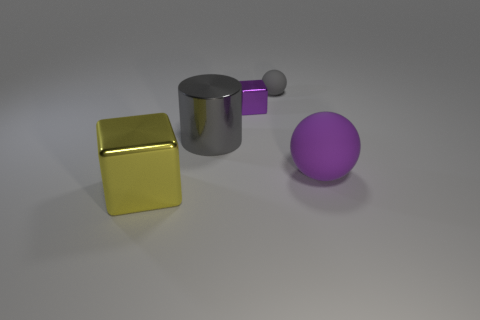What shape is the tiny purple thing that is the same material as the large yellow cube?
Keep it short and to the point. Cube. Is the material of the tiny block the same as the big sphere?
Your answer should be compact. No. Are there fewer big metal things that are on the right side of the purple matte thing than small purple shiny cubes that are behind the large yellow metallic thing?
Your answer should be very brief. Yes. What is the size of the matte sphere that is the same color as the small cube?
Make the answer very short. Large. What number of big gray cylinders are to the right of the big metallic thing in front of the large object to the right of the tiny gray matte ball?
Ensure brevity in your answer.  1. Do the large cylinder and the big ball have the same color?
Offer a very short reply. No. Are there any tiny objects of the same color as the tiny cube?
Make the answer very short. No. There is a metallic cube that is the same size as the purple matte ball; what color is it?
Ensure brevity in your answer.  Yellow. Is there a large yellow object that has the same shape as the big purple object?
Keep it short and to the point. No. There is a tiny thing that is the same color as the big matte object; what is its shape?
Provide a succinct answer. Cube. 